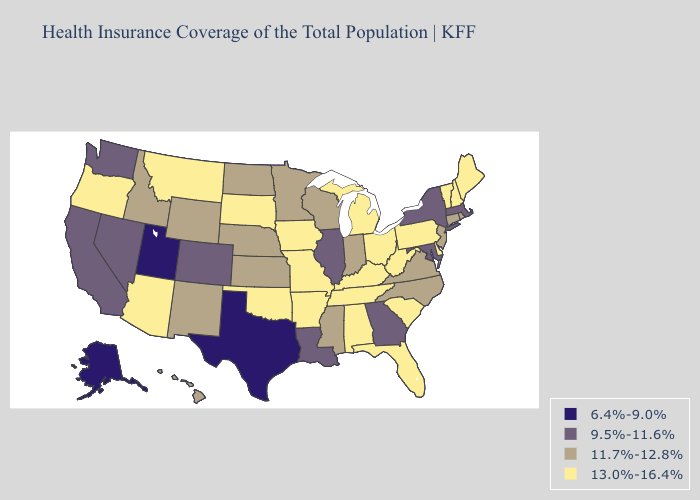Name the states that have a value in the range 13.0%-16.4%?
Keep it brief. Alabama, Arizona, Arkansas, Delaware, Florida, Iowa, Kentucky, Maine, Michigan, Missouri, Montana, New Hampshire, Ohio, Oklahoma, Oregon, Pennsylvania, South Carolina, South Dakota, Tennessee, Vermont, West Virginia. What is the lowest value in the USA?
Be succinct. 6.4%-9.0%. What is the highest value in the Northeast ?
Give a very brief answer. 13.0%-16.4%. Name the states that have a value in the range 6.4%-9.0%?
Be succinct. Alaska, Texas, Utah. Among the states that border Indiana , which have the lowest value?
Quick response, please. Illinois. What is the value of Maine?
Short answer required. 13.0%-16.4%. Which states hav the highest value in the MidWest?
Answer briefly. Iowa, Michigan, Missouri, Ohio, South Dakota. What is the value of Idaho?
Concise answer only. 11.7%-12.8%. What is the value of New York?
Quick response, please. 9.5%-11.6%. Name the states that have a value in the range 6.4%-9.0%?
Quick response, please. Alaska, Texas, Utah. Does Illinois have the lowest value in the MidWest?
Short answer required. Yes. Does North Carolina have the highest value in the South?
Keep it brief. No. Does Hawaii have a higher value than Virginia?
Keep it brief. No. What is the value of New Hampshire?
Concise answer only. 13.0%-16.4%. What is the value of Wisconsin?
Keep it brief. 11.7%-12.8%. 